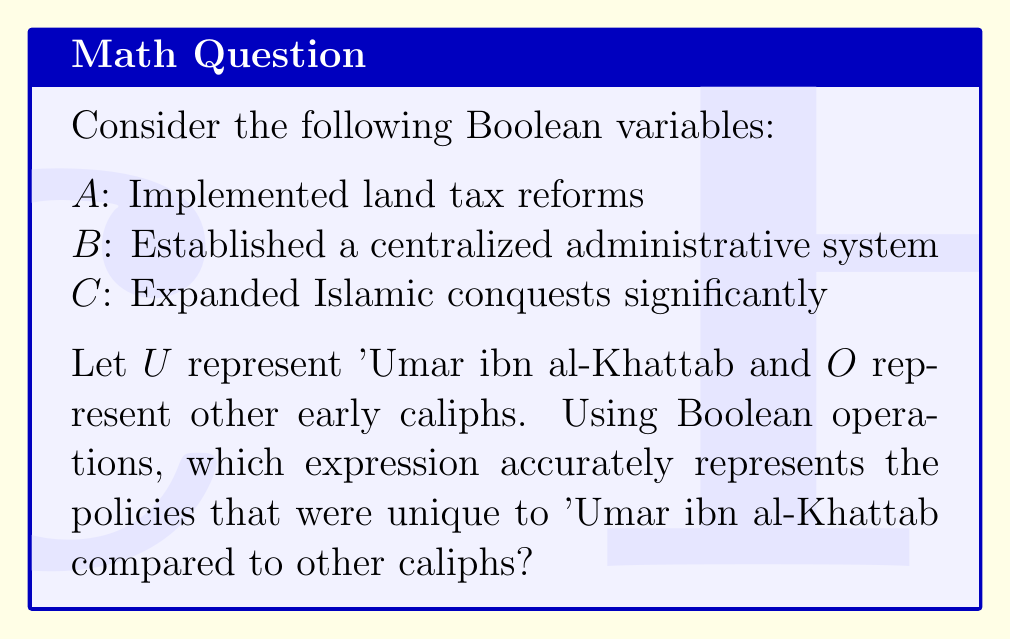What is the answer to this math problem? To solve this problem, we need to consider each policy and determine which were implemented by 'Umar ibn al-Khattab and which were implemented by other caliphs. Then, we can use Boolean operations to express the policies unique to 'Umar.

1. Land tax reforms ($A$):
   'Umar implemented significant land tax reforms, so $U_A = 1$
   Some other caliphs also implemented land taxes, so $O_A = 1$

2. Centralized administrative system ($B$):
   'Umar established a centralized system, so $U_B = 1$
   Other caliphs generally did not have such a system, so $O_B = 0$

3. Significant expansion of Islamic conquests ($C$):
   'Umar greatly expanded Islamic territories, so $U_C = 1$
   Other caliphs also engaged in conquests, so $O_C = 1$

To find policies unique to 'Umar, we need to use the AND operation ($\wedge$) between 'Umar's policies and the NOT ($\neg$) of other caliphs' policies:

$$(U_A \wedge \neg O_A) \vee (U_B \wedge \neg O_B) \vee (U_C \wedge \neg O_C)$$

Substituting the values:

$$(1 \wedge \neg 1) \vee (1 \wedge \neg 0) \vee (1 \wedge \neg 1)$$

Simplifying:

$$0 \vee 1 \vee 0 = 1$$

The only term that equals 1 is $(U_B \wedge \neg O_B)$, which represents the centralized administrative system.
Answer: $B$ 